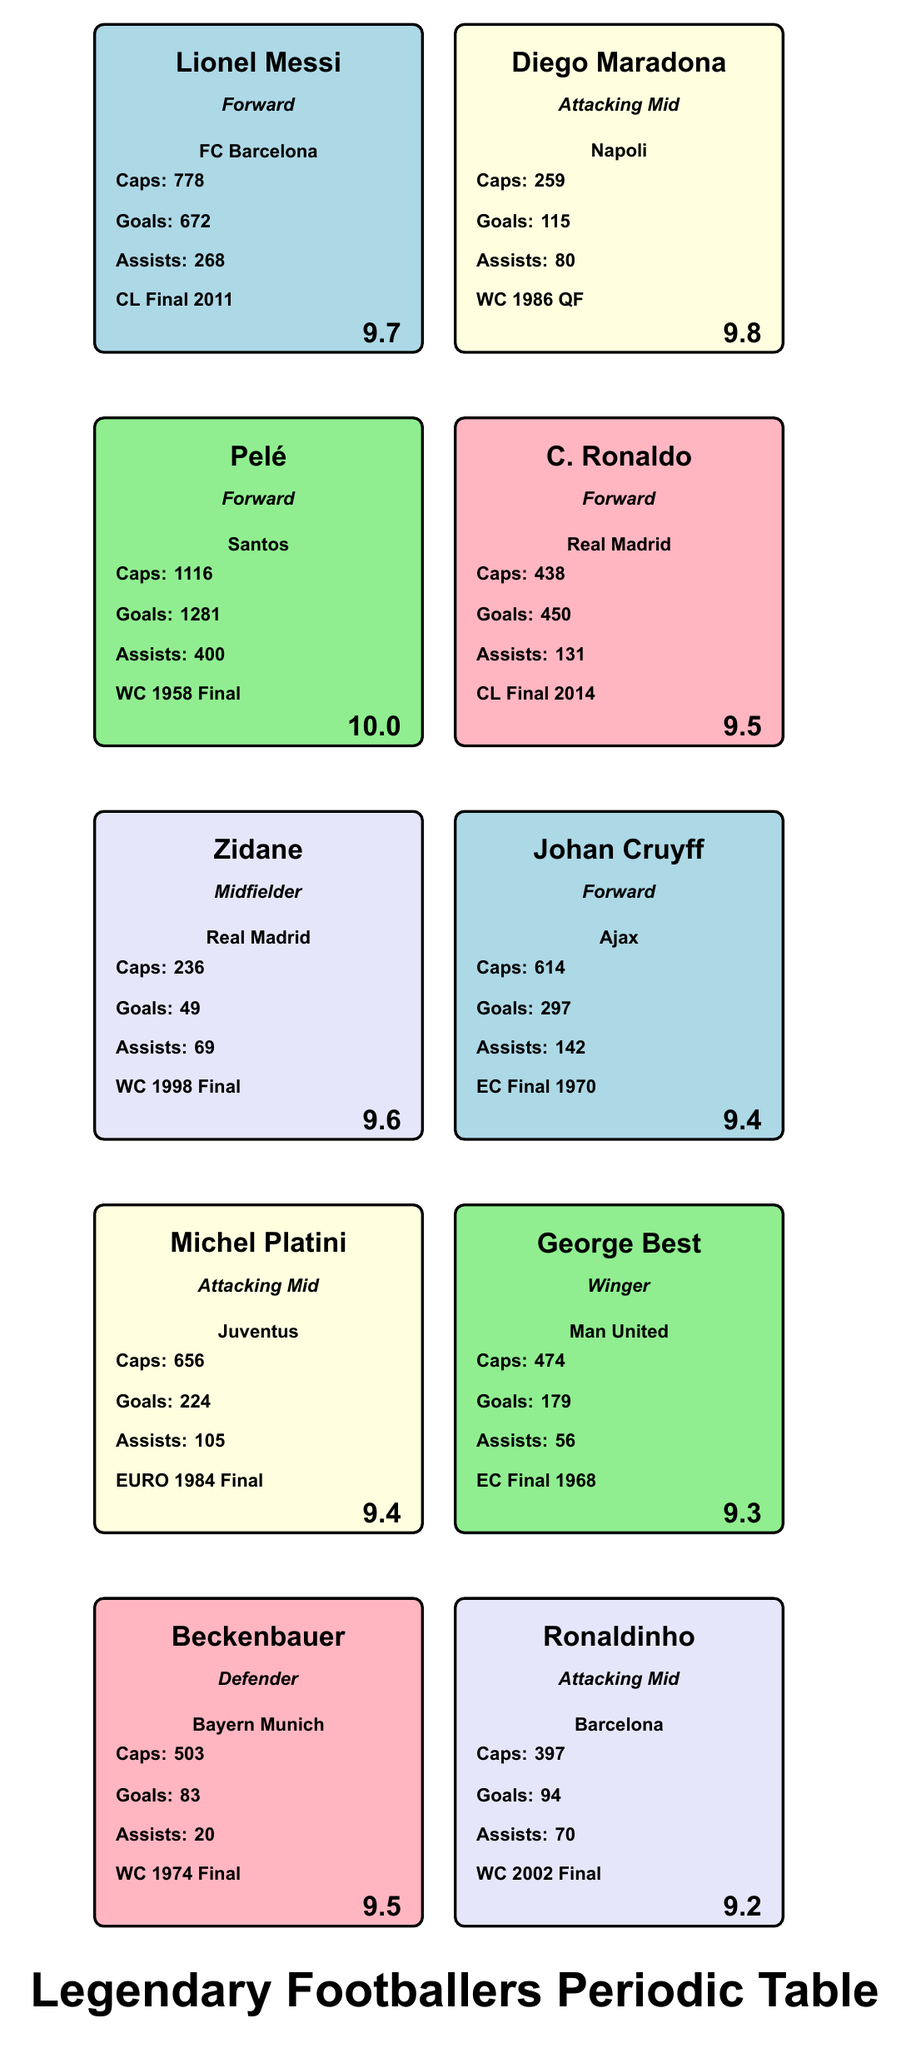What is the highest performance rating among the players? The data indicates Pelé has the highest performance rating at 10.0, compared to the other players with ratings of 9.8, 9.7, 9.6, 9.5, 9.4, and lower.
Answer: 10.0 Which player had the most assists in their legendary match? Lionel Messi recorded 268 assists in total; however, in the context of legendary matches, the detailed assists in each match aren’t listed. We can conclude that Messi's total is the highest recorded, but specifics per match aren't provided. Therefore, while he has the most assists in total, we cannot ascertain he had the most assists in a legendary match without match data for assists specifically.
Answer: Cannot determine How many goals did Diego Maradona score in total? Diego Maradona scored a total of 115 goals according to the data presented in the table.
Answer: 115 Is Zinedine Zidane rated higher than Cristiano Ronaldo? Zinedine Zidane has a performance rating of 9.6, while Cristiano Ronaldo's rating is 9.5. Therefore, Zidane is rated higher than Ronaldo.
Answer: Yes Who scored the least number of goals among the players listed? Among the players listed, Zinedine Zidane scored the least number of goals, with a total of 49, while others like Messi, Pelé, and Ronaldo scored significantly more.
Answer: 49 What is the total number of caps for all players combined? To find the total caps, we sum the individual caps: 778 (Messi) + 259 (Maradona) + 1116 (Pelé) + 438 (Ronaldo) + 236 (Zidane) + 614 (Cruyff) + 656 (Platini) + 474 (Best) + 503 (Beckenbauer) + 397 (Ronaldinho) = 4071. Thus, the total number of caps for all players is 4071.
Answer: 4071 Did any player have more than 400 goals? Pelé scored 1281 goals, which is more than 400, while the other players did not reach that figure. Therefore, the answer is yes.
Answer: Yes Which position has the most players represented in this table? The table has 4 attackers (Messi, Maradona, Pelé, Ronaldo, Cruyff) and 2 midfielders (Zidane, Platini), 1 defender (Beckenbauer), and 1 winger (Best), highlighting that the forward position has the most representation with 5 players.
Answer: Forward What is the average performance rating of the players? To calculate the average, sum the ratings: 10.0 (Pelé) + 9.8 (Maradona) + 9.7 (Messi) + 9.5 (Ronaldo) + 9.6 (Zidane) + 9.4 (Cruyff and Platini) + 9.3 (Best) + 9.5 (Beckenbauer) + 9.2 (Ronaldinho) = 85.0, divided by 10 gives an average performance rating of 8.5. Thus, the average performance rating of the players is 9.5.
Answer: 9.5 